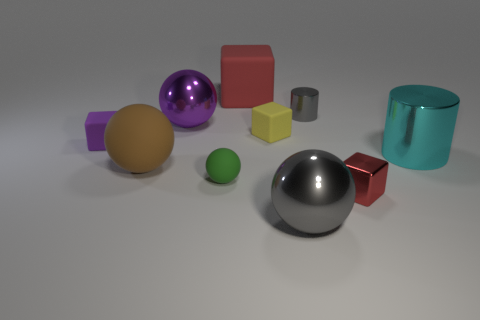Subtract all purple matte cubes. How many cubes are left? 3 Subtract all yellow cubes. How many cubes are left? 3 Subtract all big cyan cylinders. Subtract all big cyan shiny things. How many objects are left? 8 Add 6 green things. How many green things are left? 7 Add 6 brown blocks. How many brown blocks exist? 6 Subtract 0 gray cubes. How many objects are left? 10 Subtract all cylinders. How many objects are left? 8 Subtract 3 blocks. How many blocks are left? 1 Subtract all cyan cylinders. Subtract all green spheres. How many cylinders are left? 1 Subtract all brown cylinders. How many brown spheres are left? 1 